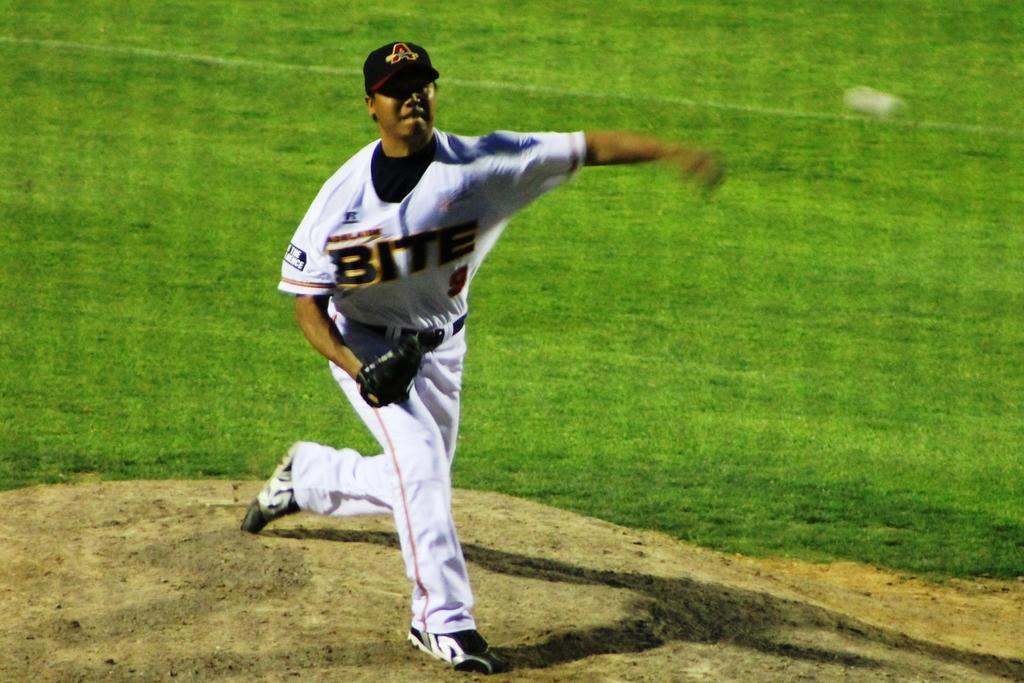Who is the main subject in the image? There is a person in the center of the image. What is the person doing in the image? The person is throwing a ball. What type of surface is at the bottom of the image? There is grass and sand at the bottom of the image. What type of alarm is going off in the image? There is no alarm present in the image. What color is the vest the person is wearing in the image? The provided facts do not mention any vest being worn by the person in the image. 